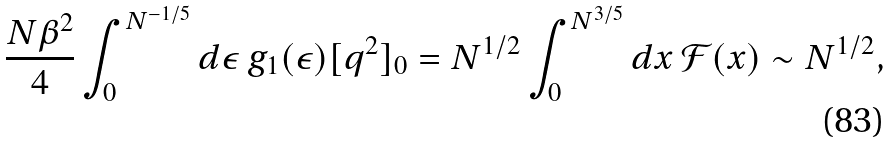<formula> <loc_0><loc_0><loc_500><loc_500>\frac { N \beta ^ { 2 } } { 4 } \int _ { 0 } ^ { N ^ { - 1 / 5 } } d \epsilon \, g _ { 1 } ( \epsilon ) [ q ^ { 2 } ] _ { 0 } & = N ^ { 1 / 2 } \int _ { 0 } ^ { N ^ { 3 / 5 } } d x \, \mathcal { F } ( x ) \sim N ^ { 1 / 2 } ,</formula> 